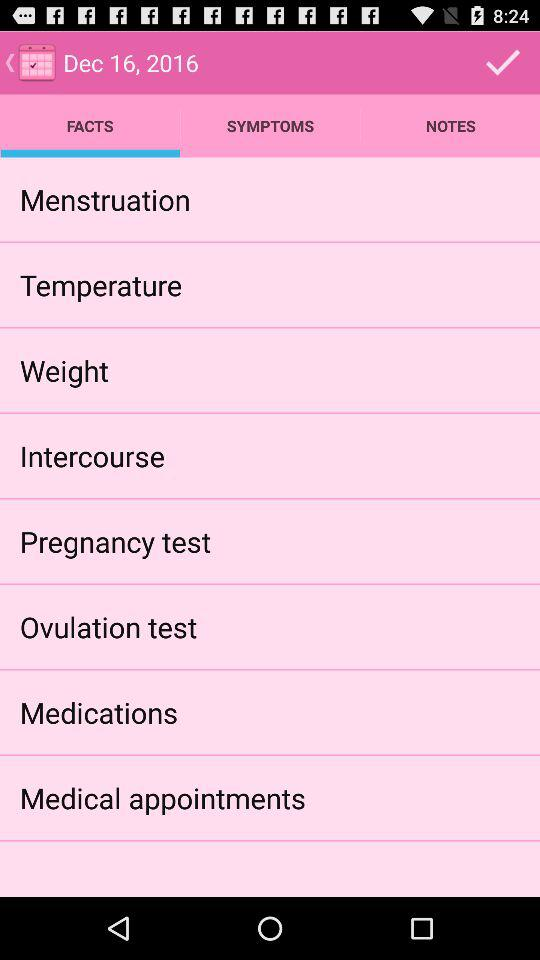Which symptoms are selected?
When the provided information is insufficient, respond with <no answer>. <no answer> 